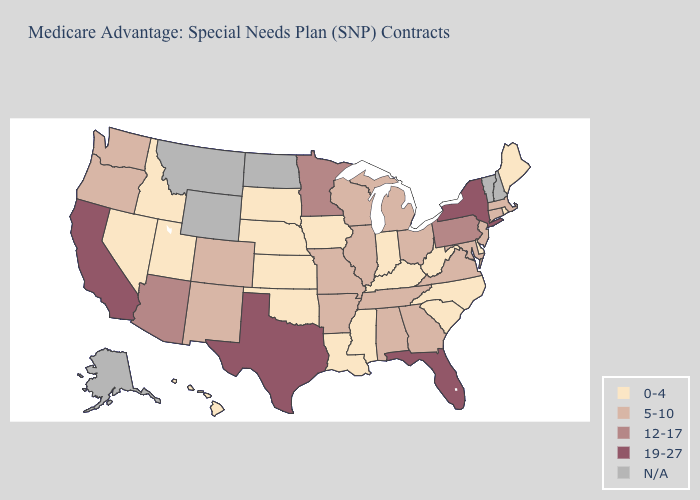Is the legend a continuous bar?
Be succinct. No. What is the lowest value in the South?
Write a very short answer. 0-4. Is the legend a continuous bar?
Concise answer only. No. Does Maryland have the lowest value in the South?
Quick response, please. No. Among the states that border Iowa , does Nebraska have the lowest value?
Answer briefly. Yes. How many symbols are there in the legend?
Write a very short answer. 5. What is the lowest value in the USA?
Answer briefly. 0-4. What is the value of North Carolina?
Give a very brief answer. 0-4. What is the value of Oregon?
Answer briefly. 5-10. Does Florida have the highest value in the USA?
Quick response, please. Yes. What is the highest value in the USA?
Concise answer only. 19-27. Does Rhode Island have the lowest value in the Northeast?
Keep it brief. Yes. What is the value of Florida?
Short answer required. 19-27. Is the legend a continuous bar?
Write a very short answer. No. 